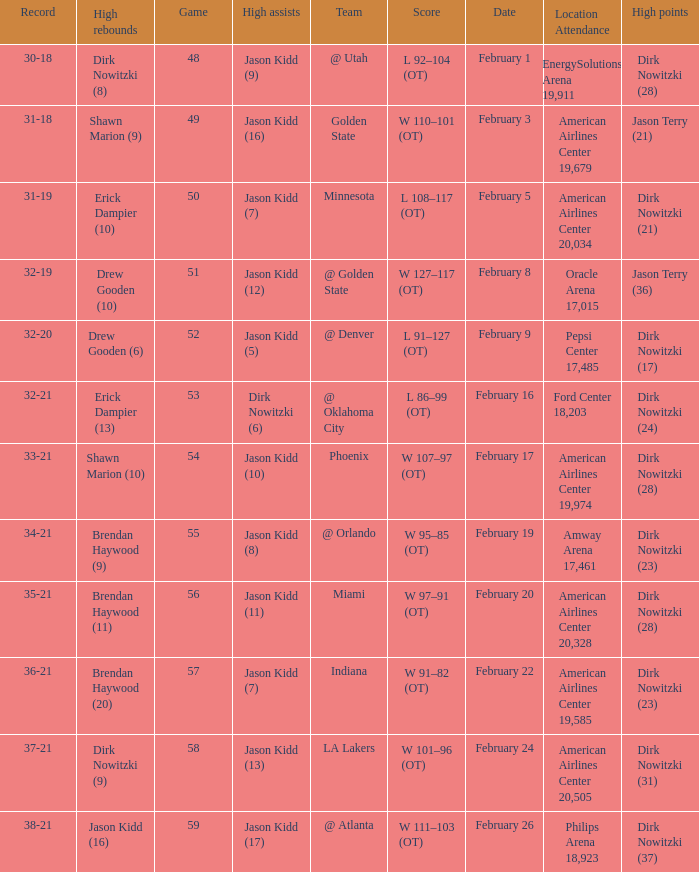Who had the most high assists with a record of 32-19? Jason Kidd (12). 